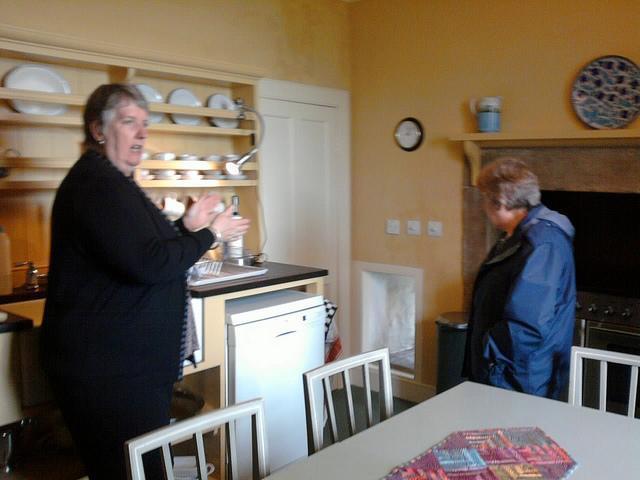How many people are there?
Give a very brief answer. 2. How many chairs are in the picture?
Give a very brief answer. 3. 